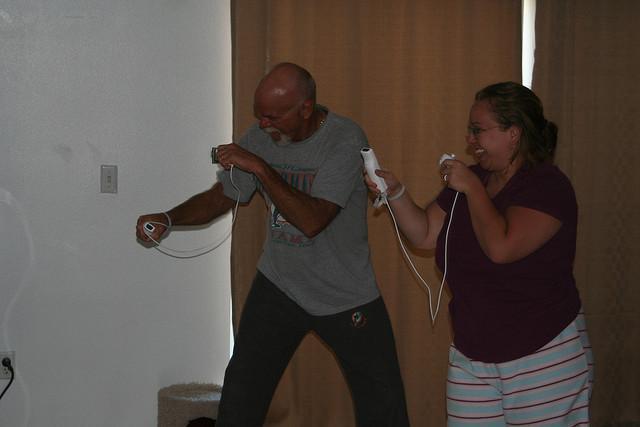How many archers are pictured?
Give a very brief answer. 0. How many people are there?
Give a very brief answer. 2. How many women are playing?
Give a very brief answer. 1. How many people are female?
Give a very brief answer. 1. 